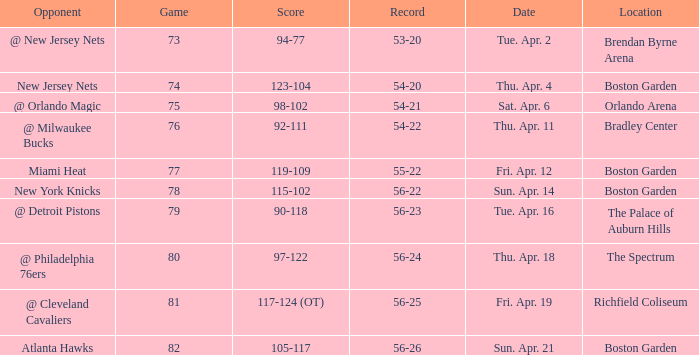Where was game 78 held? Boston Garden. 